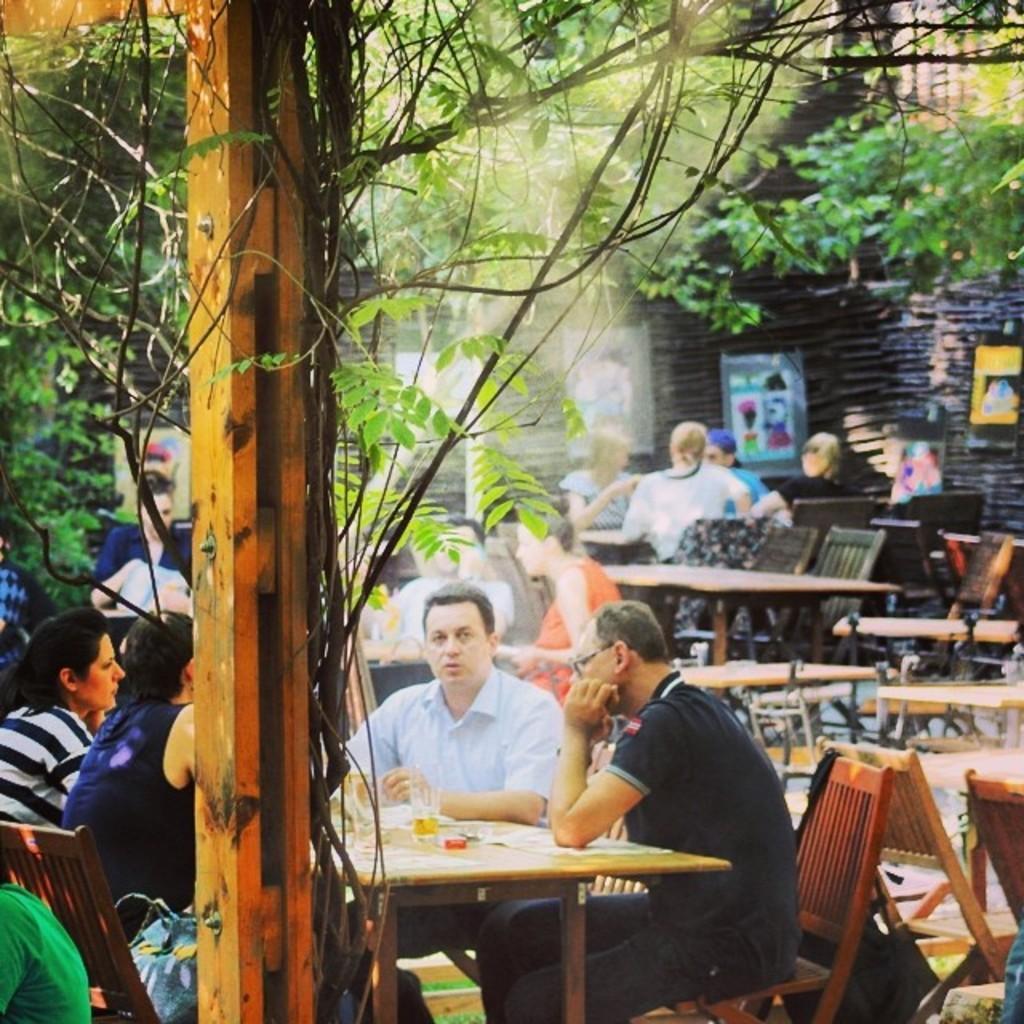Could you give a brief overview of what you see in this image? In the background I can see trees. Here is a man wearing blue shirt. Here is another person wearing black t-shirt and there are two women sitting on the chairs. Here I can see a table and glass on it. In the background there are four people, one person is wearing blue cap. And here is a wall, there is some posters to this wall. And here it is a blue bag beside the woman. 